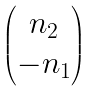<formula> <loc_0><loc_0><loc_500><loc_500>\begin{pmatrix} n _ { 2 } \\ - n _ { 1 } \end{pmatrix}</formula> 